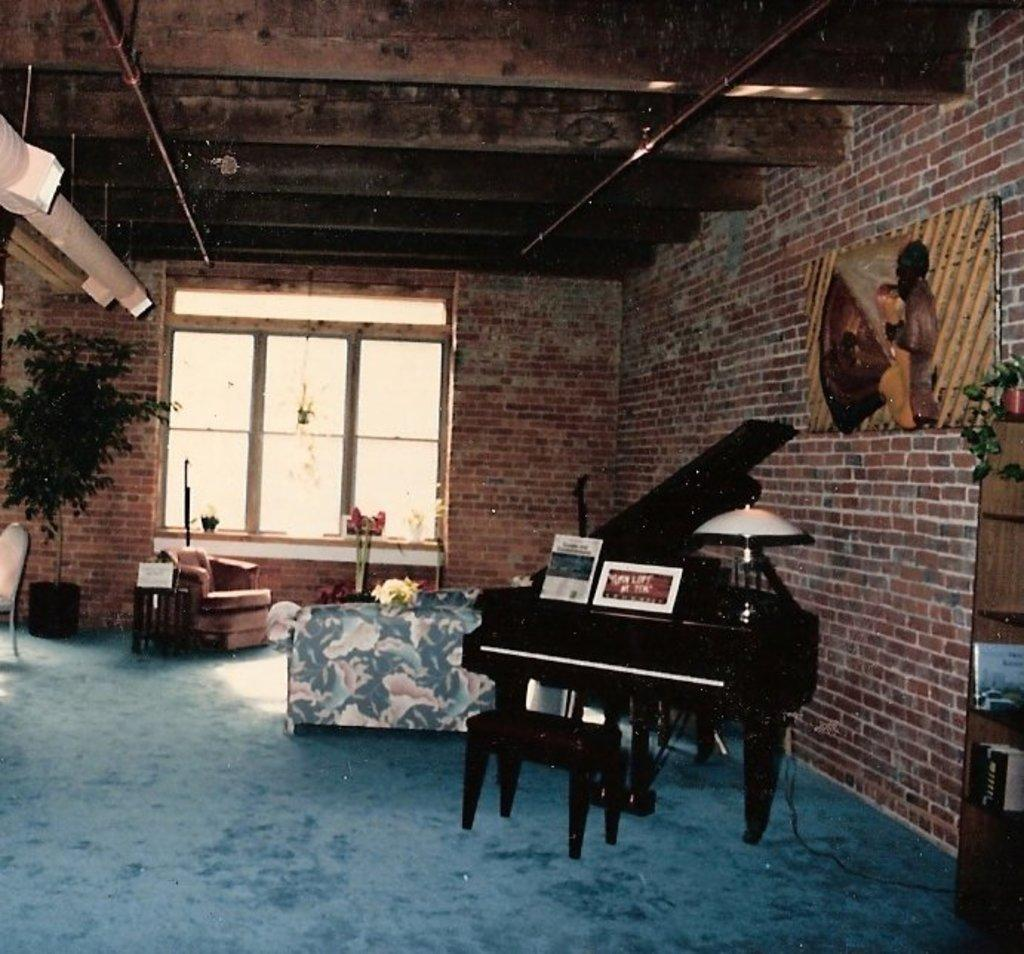What musical instrument is present in the image? There is a piano in the image. What items are placed on top of the piano? There are two notebooks on top of the piano. What can be seen in the background of the image? There is a glass painting and a window in the background of the image. How is the roof designed in the image? The roof is beautifully designed. What type of fork is used to play the piano in the image? There is no fork present in the image, and forks are not used to play the piano. 